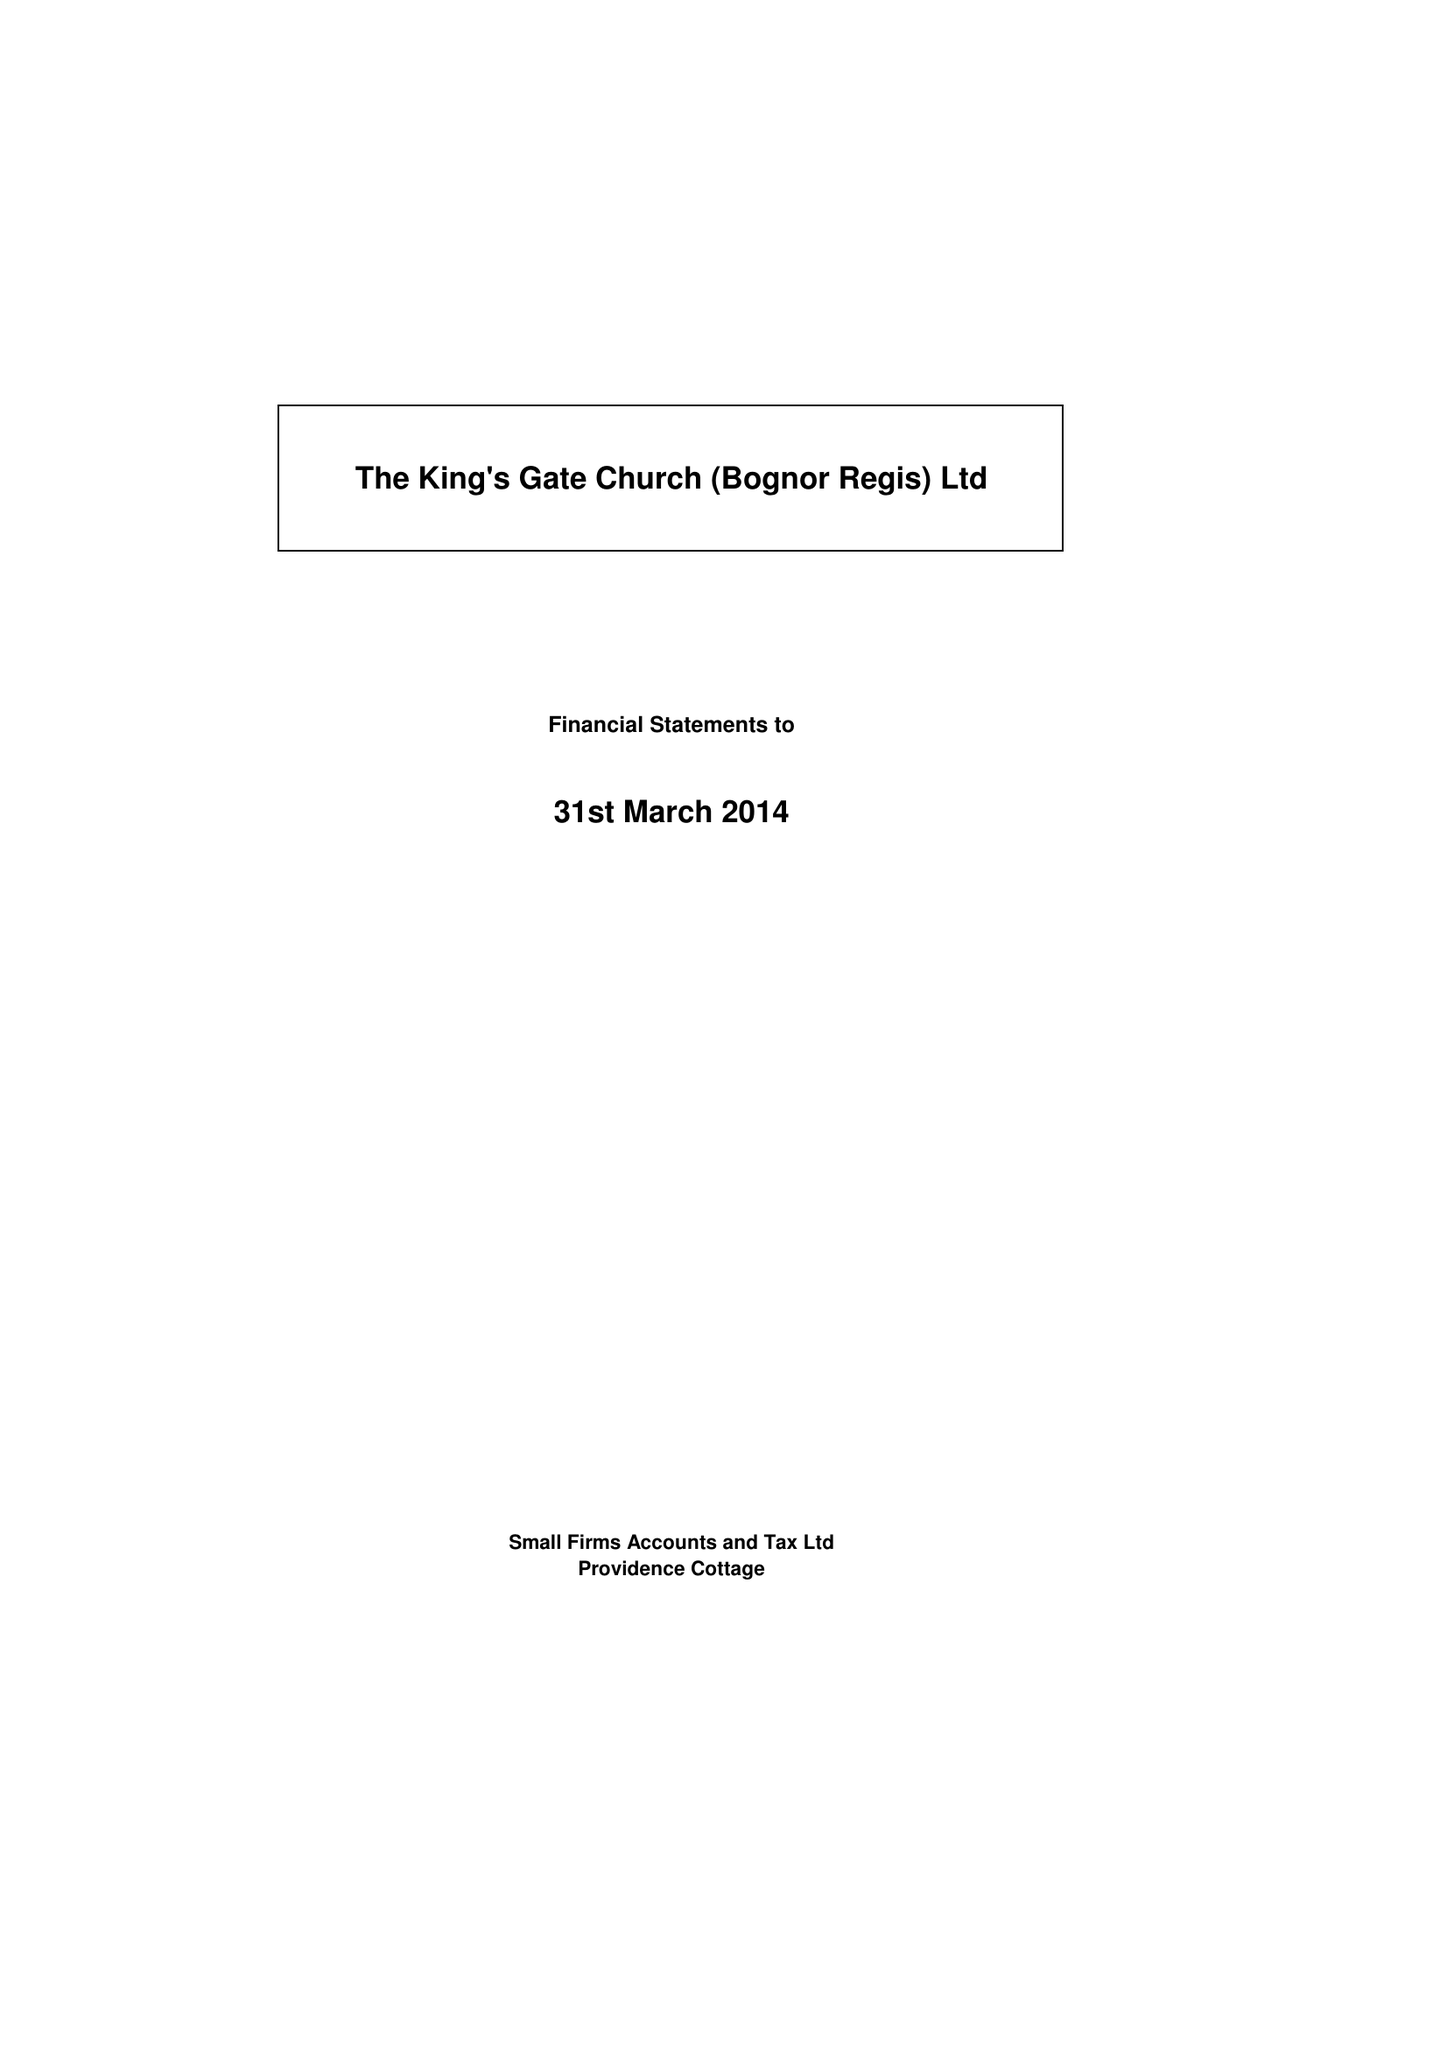What is the value for the address__post_town?
Answer the question using a single word or phrase. BOGNOR REGIS 